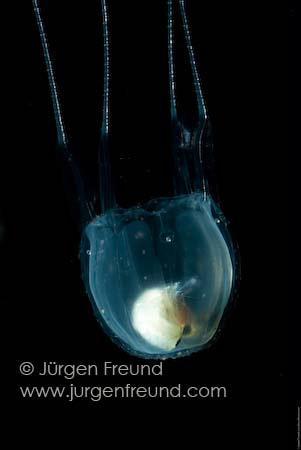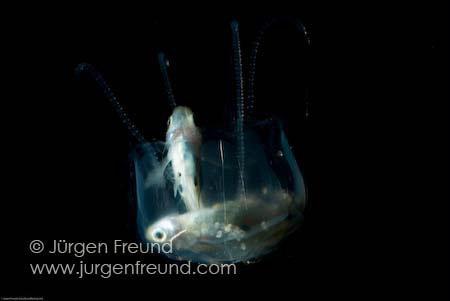The first image is the image on the left, the second image is the image on the right. Analyze the images presented: Is the assertion "One of the images shows a single fish being pulled in on the tentacles of a lone jellyfish" valid? Answer yes or no. No. The first image is the image on the left, the second image is the image on the right. Assess this claim about the two images: "There is at least one moving jellyfish with a rounded crown lit up blue due to the blue background.". Correct or not? Answer yes or no. No. 